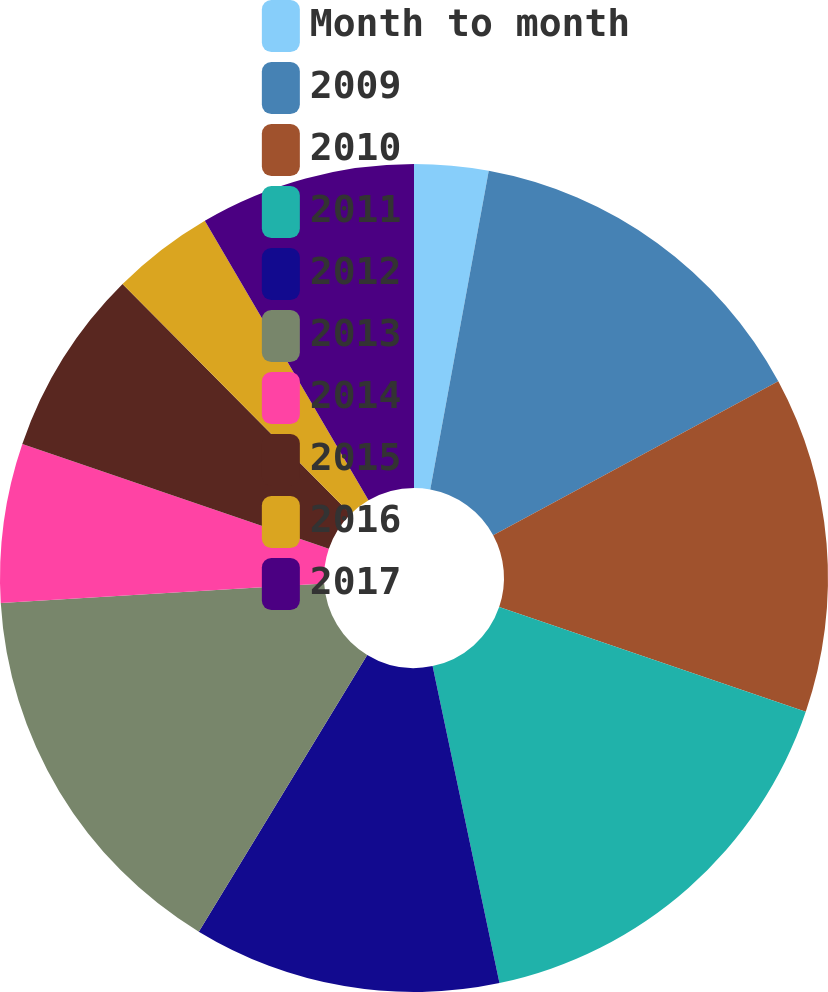Convert chart to OTSL. <chart><loc_0><loc_0><loc_500><loc_500><pie_chart><fcel>Month to month<fcel>2009<fcel>2010<fcel>2011<fcel>2012<fcel>2013<fcel>2014<fcel>2015<fcel>2016<fcel>2017<nl><fcel>2.89%<fcel>14.23%<fcel>13.12%<fcel>16.45%<fcel>12.01%<fcel>15.34%<fcel>6.21%<fcel>7.32%<fcel>4.0%<fcel>8.43%<nl></chart> 